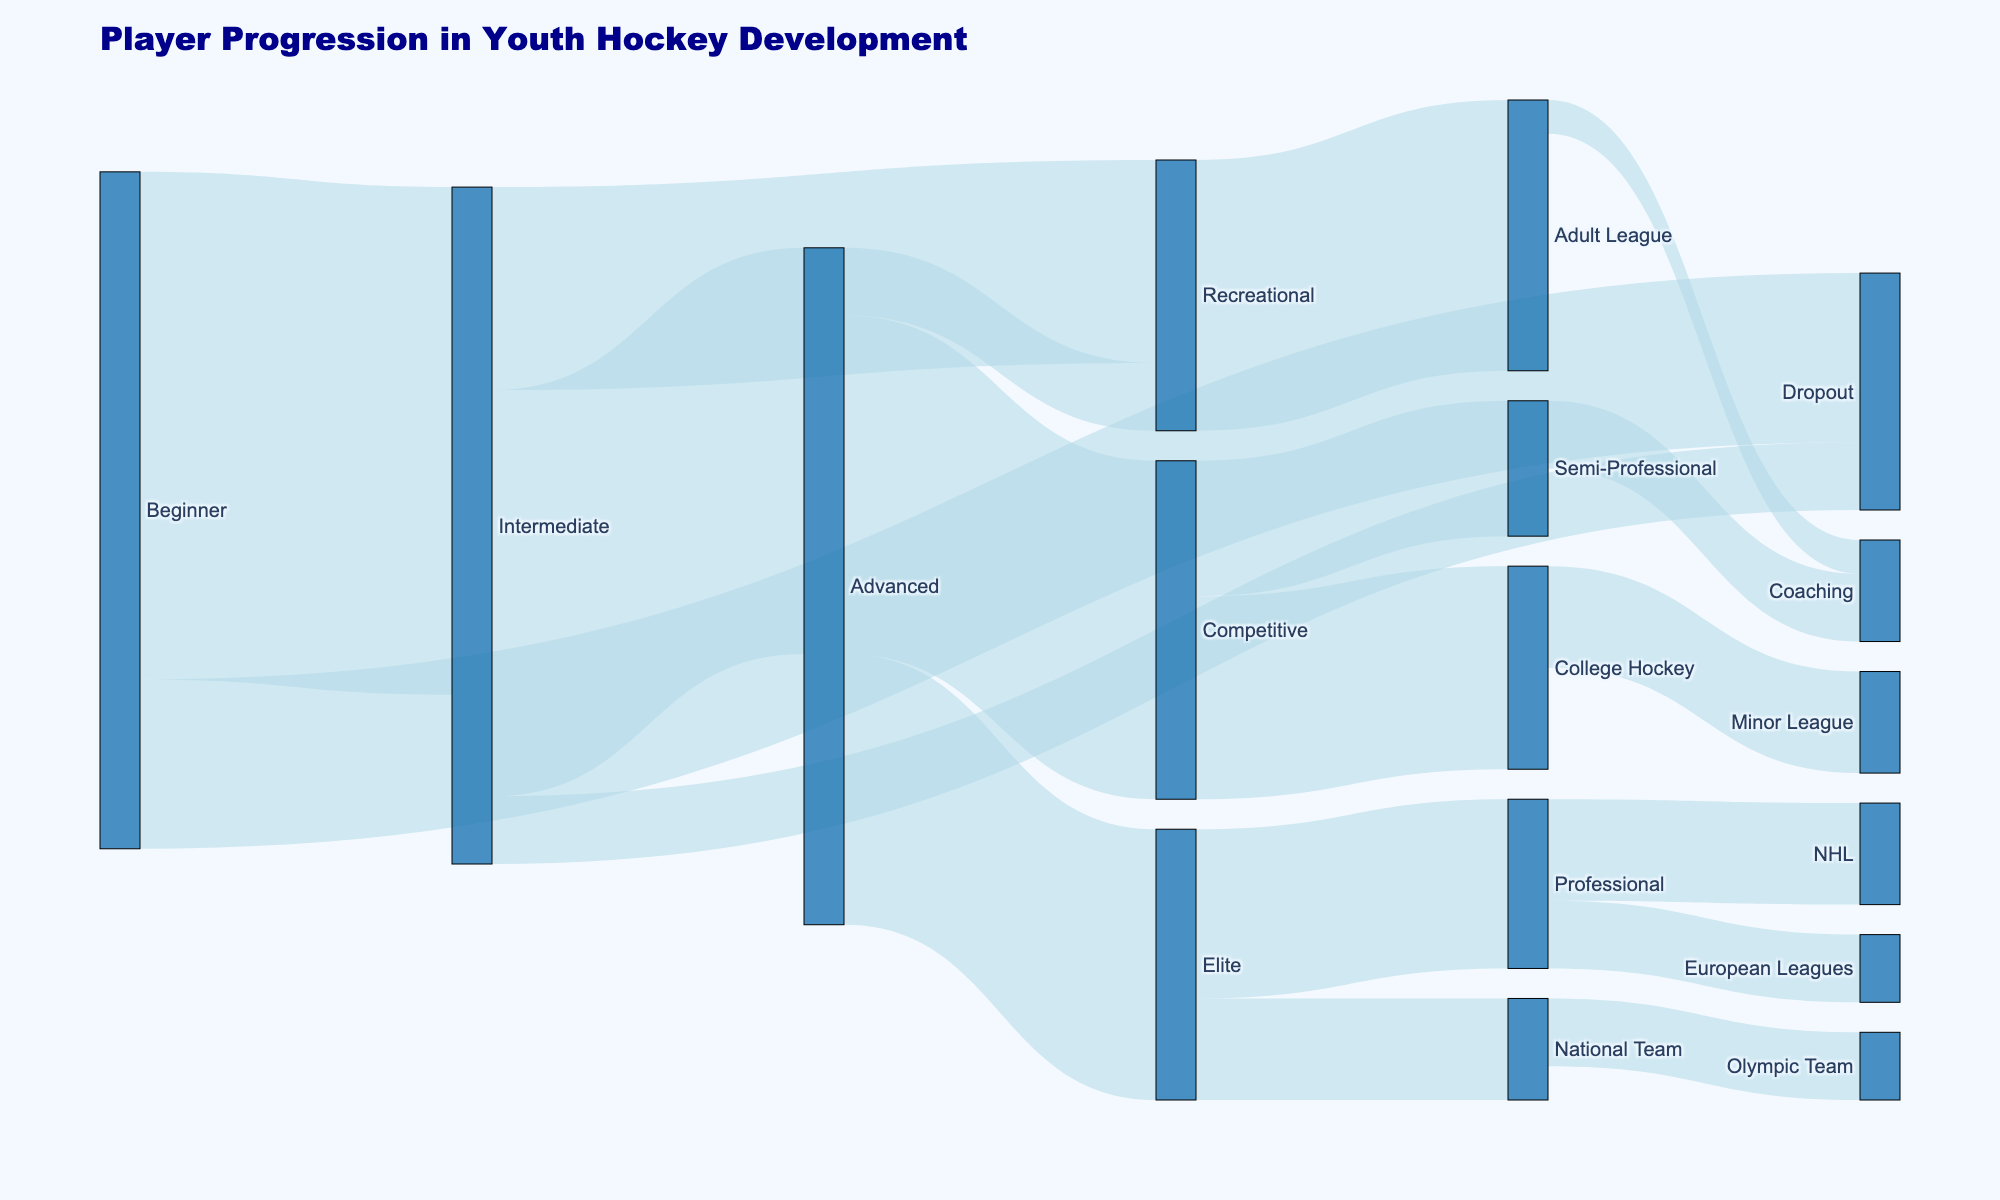What is the title of the Sankey diagram? The title is prominently displayed at the top of the diagram.
Answer: Player Progression in Youth Hockey Development In the diagram, which skill level has the highest number of players moving on to an 'Elite' skill level? Look at the number of players flowing into 'Elite' from other levels. 'Intermediate' directly sends 60 players to 'Advanced', which then sends 40 to 'Elite'.
Answer: Advanced How many players drop out before reaching the 'Intermediate' level? Follow the flow starting at 'Beginner' that leads to 'Dropout'. The quantity is indicated directly by the flow magnitude.
Answer: 25 What percentage of players, starting from 'Beginner', end up in the 'National Team'? Calculate the number reaching 'National Team' via 'Elite' and compare it to the total starting at 'Beginner'. Calculate 15 reaching 'National Team' out of 100 starting at 'Beginner'.
Answer: 15% Which skill level has the smallest number of players flowing into the 'Professional' level? Identify all flows that end in 'Professional' and check the incoming player numbers. 'Elite' flows 25 players while 'College Hockey' flows none.
Answer: Elite Out of 'Recreational' level players, how many continue to the 'Adult League'? Locate the flow from 'Recreational' to 'Adult League' and refer to the quantity indicated.
Answer: 40 What is the total number of players who reach an 'Advanced' level? Sum up the flows leading to 'Advanced', particularly arising from 'Intermediate' level. Adding up, 60 players advance from 'Intermediate'.
Answer: 60 Which path has more players, from 'Intermediate' to 'Recreational' or from 'Advanced' to 'Recreational'? Compare the flows' magnitudes from 'Intermediate' to 'Recreational' with those from 'Advanced' to 'Recreational'.
Answer: Intermediate to Recreational From 'Competitive', which subsequent level has the least players? Identify subsequent flows from 'Competitive' and compare their quantities, 'Semi-Professional’ has 20.
Answer: Semi-Professional How many players transition from 'Elite' to the 'Olympic Team'? Check the flow directly connecting 'Elite' to 'Olympic Team' and refer to the player count indicated by that arrow.
Answer: 10 